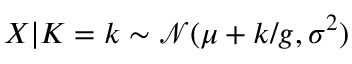<formula> <loc_0><loc_0><loc_500><loc_500>X | K = k \sim \mathcal { N } ( \mu + k / g , \sigma ^ { 2 } )</formula> 